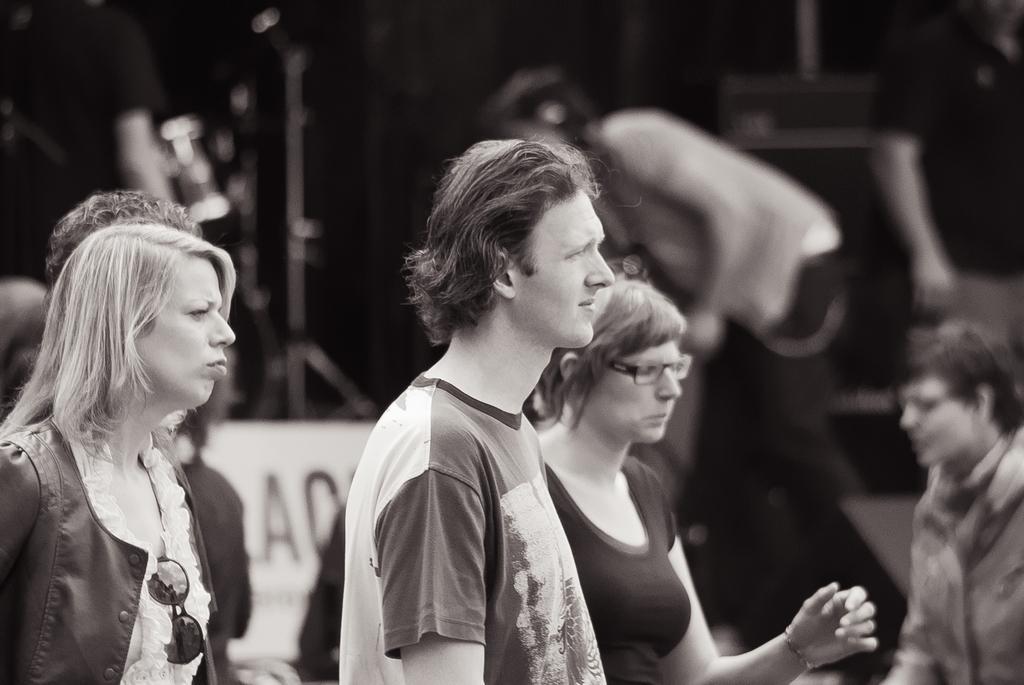How would you summarize this image in a sentence or two? This is a black and white image. In front of the image there are few people standing. Behind them there are few people and also there is a blur background. 